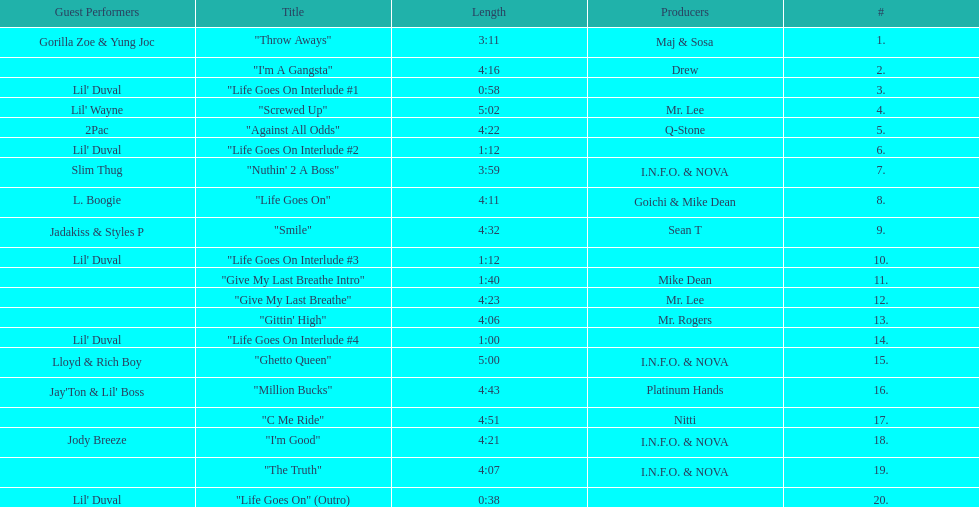How many songs are featured on trae's album titled "life goes on"? 20. 